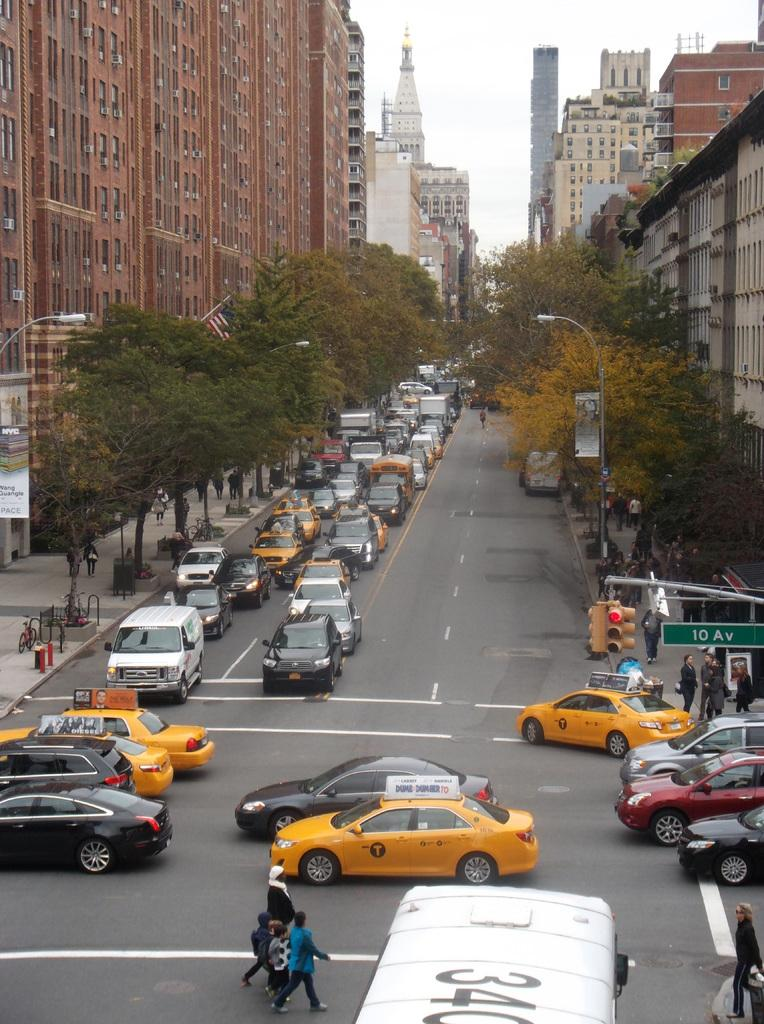<image>
Summarize the visual content of the image. A group of people cross the busy intersection along 10th Avenue. 